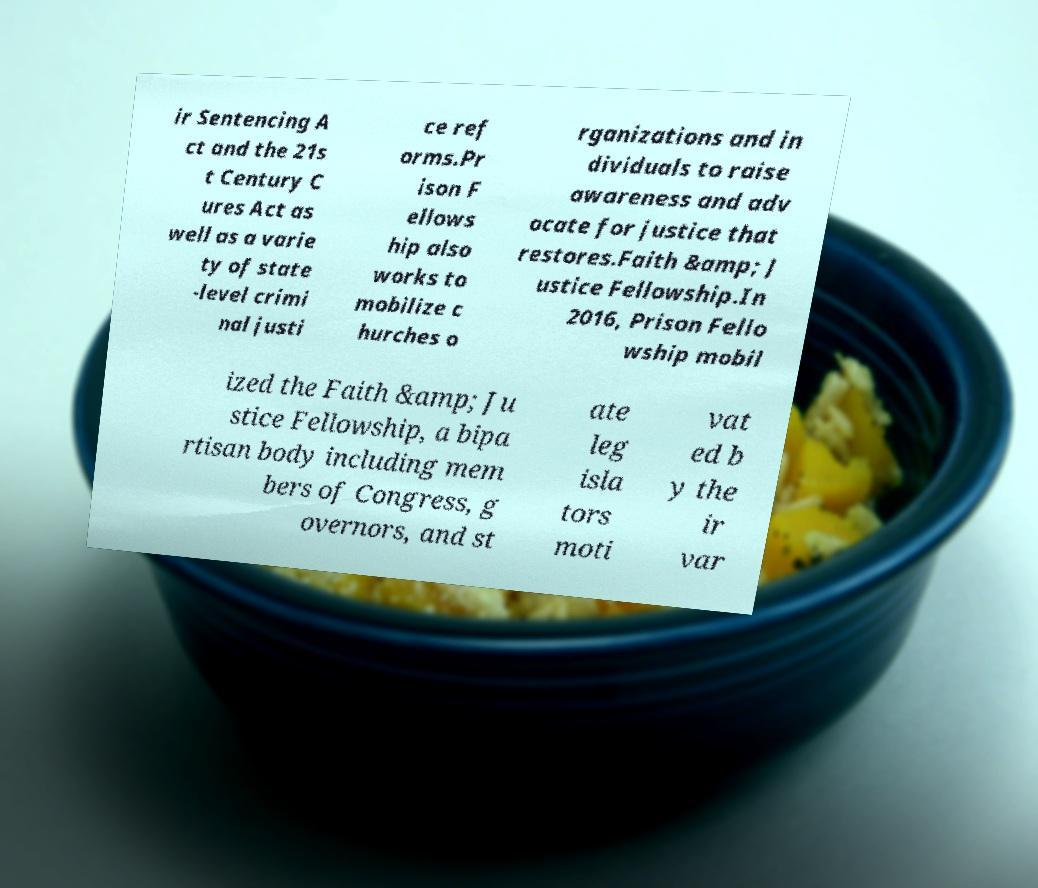Can you read and provide the text displayed in the image?This photo seems to have some interesting text. Can you extract and type it out for me? ir Sentencing A ct and the 21s t Century C ures Act as well as a varie ty of state -level crimi nal justi ce ref orms.Pr ison F ellows hip also works to mobilize c hurches o rganizations and in dividuals to raise awareness and adv ocate for justice that restores.Faith &amp; J ustice Fellowship.In 2016, Prison Fello wship mobil ized the Faith &amp; Ju stice Fellowship, a bipa rtisan body including mem bers of Congress, g overnors, and st ate leg isla tors moti vat ed b y the ir var 